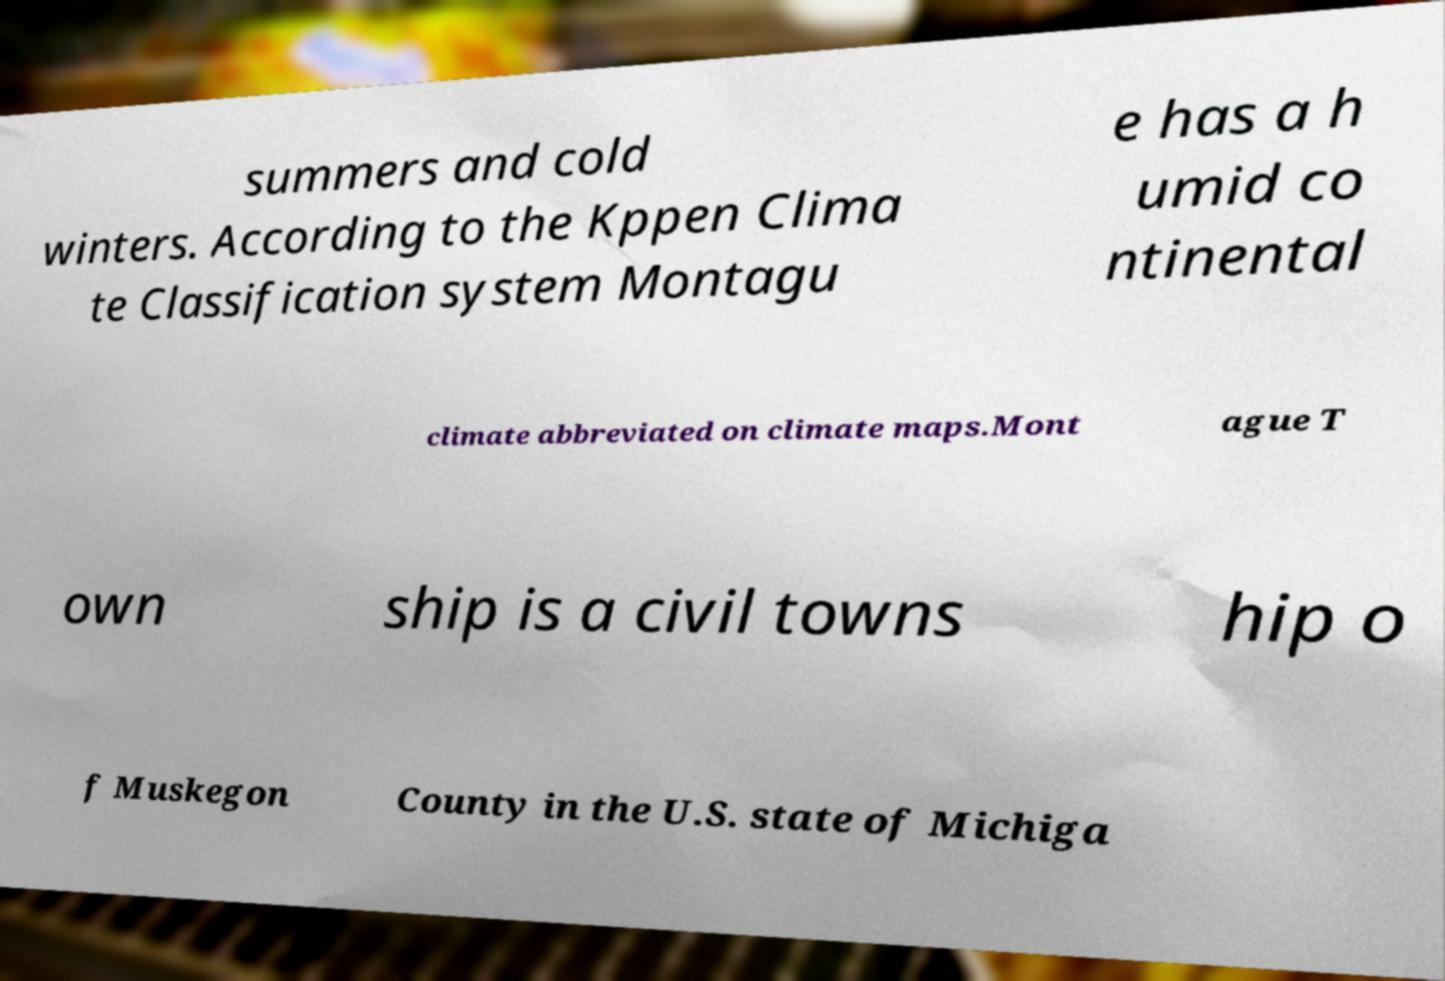Can you read and provide the text displayed in the image?This photo seems to have some interesting text. Can you extract and type it out for me? summers and cold winters. According to the Kppen Clima te Classification system Montagu e has a h umid co ntinental climate abbreviated on climate maps.Mont ague T own ship is a civil towns hip o f Muskegon County in the U.S. state of Michiga 